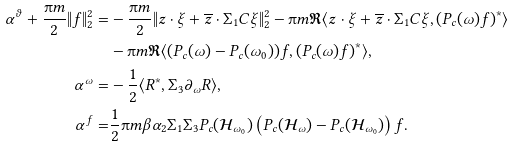<formula> <loc_0><loc_0><loc_500><loc_500>\alpha ^ { \vartheta } + \frac { \i m } { 2 } \| f \| _ { 2 } ^ { 2 } = & - \frac { \i m } { 2 } \| z \cdot \xi + \overline { z } \cdot \Sigma _ { 1 } C \xi \| _ { 2 } ^ { 2 } - \i m \Re \langle z \cdot \xi + \overline { z } \cdot \Sigma _ { 1 } C \xi , ( P _ { c } ( \omega ) f ) ^ { * } \rangle \\ & - \i m \Re \langle ( P _ { c } ( \omega ) - P _ { c } ( \omega _ { 0 } ) ) f , ( P _ { c } ( \omega ) f ) ^ { * } \rangle , \\ \alpha ^ { \omega } = & - \frac { 1 } { 2 } \langle R ^ { * } , \Sigma _ { 3 } \partial _ { \omega } R \rangle , \\ \alpha ^ { f } = & \frac { 1 } { 2 } \i m \beta \alpha _ { 2 } \Sigma _ { 1 } \Sigma _ { 3 } P _ { c } ( \mathcal { H } _ { \omega _ { 0 } } ) \left ( P _ { c } ( \mathcal { H } _ { \omega } ) - P _ { c } ( \mathcal { H } _ { \omega _ { 0 } } ) \right ) f .</formula> 